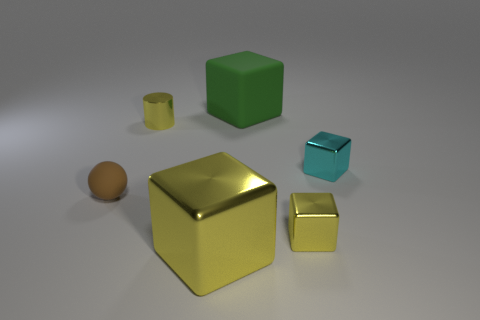Subtract all tiny yellow metallic cubes. How many cubes are left? 3 Add 3 small gray cubes. How many objects exist? 9 Subtract all cyan blocks. How many blocks are left? 3 Subtract all green cubes. Subtract all red spheres. How many cubes are left? 3 Subtract all cyan cylinders. How many gray blocks are left? 0 Subtract all large objects. Subtract all tiny cyan shiny blocks. How many objects are left? 3 Add 3 tiny metal blocks. How many tiny metal blocks are left? 5 Add 2 tiny purple objects. How many tiny purple objects exist? 2 Subtract 1 brown balls. How many objects are left? 5 Subtract all cylinders. How many objects are left? 5 